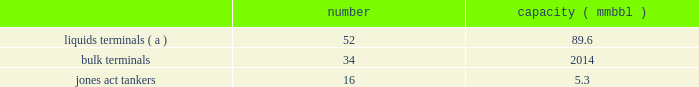( c ) effective january 1 , 2019 , these assets were transferred from the products pipelines business segment to the natural gas pipelines business segment .
( d ) effective january 1 , 2019 , a small number of terminals were transferred between the products pipelines and terminals business segments .
Competition our products pipelines 2019 pipeline operations compete against proprietary pipelines owned and operated by major oil companies , other independent products pipelines , trucking and marine transportation firms ( for short-haul movements of products ) and railcars .
Our products pipelines 2019 terminal operations compete with proprietary terminals owned and operated by major oil companies and other independent terminal operators , and our transmix operations compete with refineries owned by major oil companies and independent transmix facilities .
Terminals our terminals business segment includes the operations of our refined petroleum product , crude oil , chemical , ethanol and other liquid terminal facilities ( other than those included in the products pipelines business segment ) and all of our petroleum coke , metal and ores facilities .
Our terminals are located throughout the u.s .
And in portions of canada .
We believe the location of our facilities and our ability to provide flexibility to customers help attract new and retain existing customers at our terminals and provide expansion opportunities .
We often classify our terminal operations based on the handling of either liquids or dry-bulk material products .
In addition , terminals 2019 marine operations include jones act-qualified product tankers that provide marine transportation of crude oil , condensate and refined petroleum products between u.s .
Ports .
The following summarizes our terminals business segment assets , as of december 31 , 2018 : number capacity ( mmbbl ) .
_______ ( a ) effective january 1 , 2019 , a small number of terminals were transferred between the terminals and products pipelines business segments .
Competition we are one of the largest independent operators of liquids terminals in north america , based on barrels of liquids terminaling capacity .
Our liquids terminals compete with other publicly or privately held independent liquids terminals , and terminals owned by oil , chemical , pipeline , and refining companies .
Our bulk terminals compete with numerous independent terminal operators , terminals owned by producers and distributors of bulk commodities , stevedoring companies and other industrial companies opting not to outsource terminaling services .
In some locations , competitors are smaller , independent operators with lower cost structures .
Our jones act-qualified product tankers compete with other jones act qualified vessel fleets .
Our co2 business segment produces , transports , and markets co2 for use in enhanced oil recovery projects as a flooding medium for recovering crude oil from mature oil fields .
Our co2 pipelines and related assets allow us to market a complete package of co2 supply and transportation services to our customers .
We also hold ownership interests in several oil-producing fields and own a crude oil pipeline , all located in the permian basin region of west texas. .
What percent of storage facilities are liquid terminals? 
Computations: (52 / ((52 + 34) + 16))
Answer: 0.5098. 